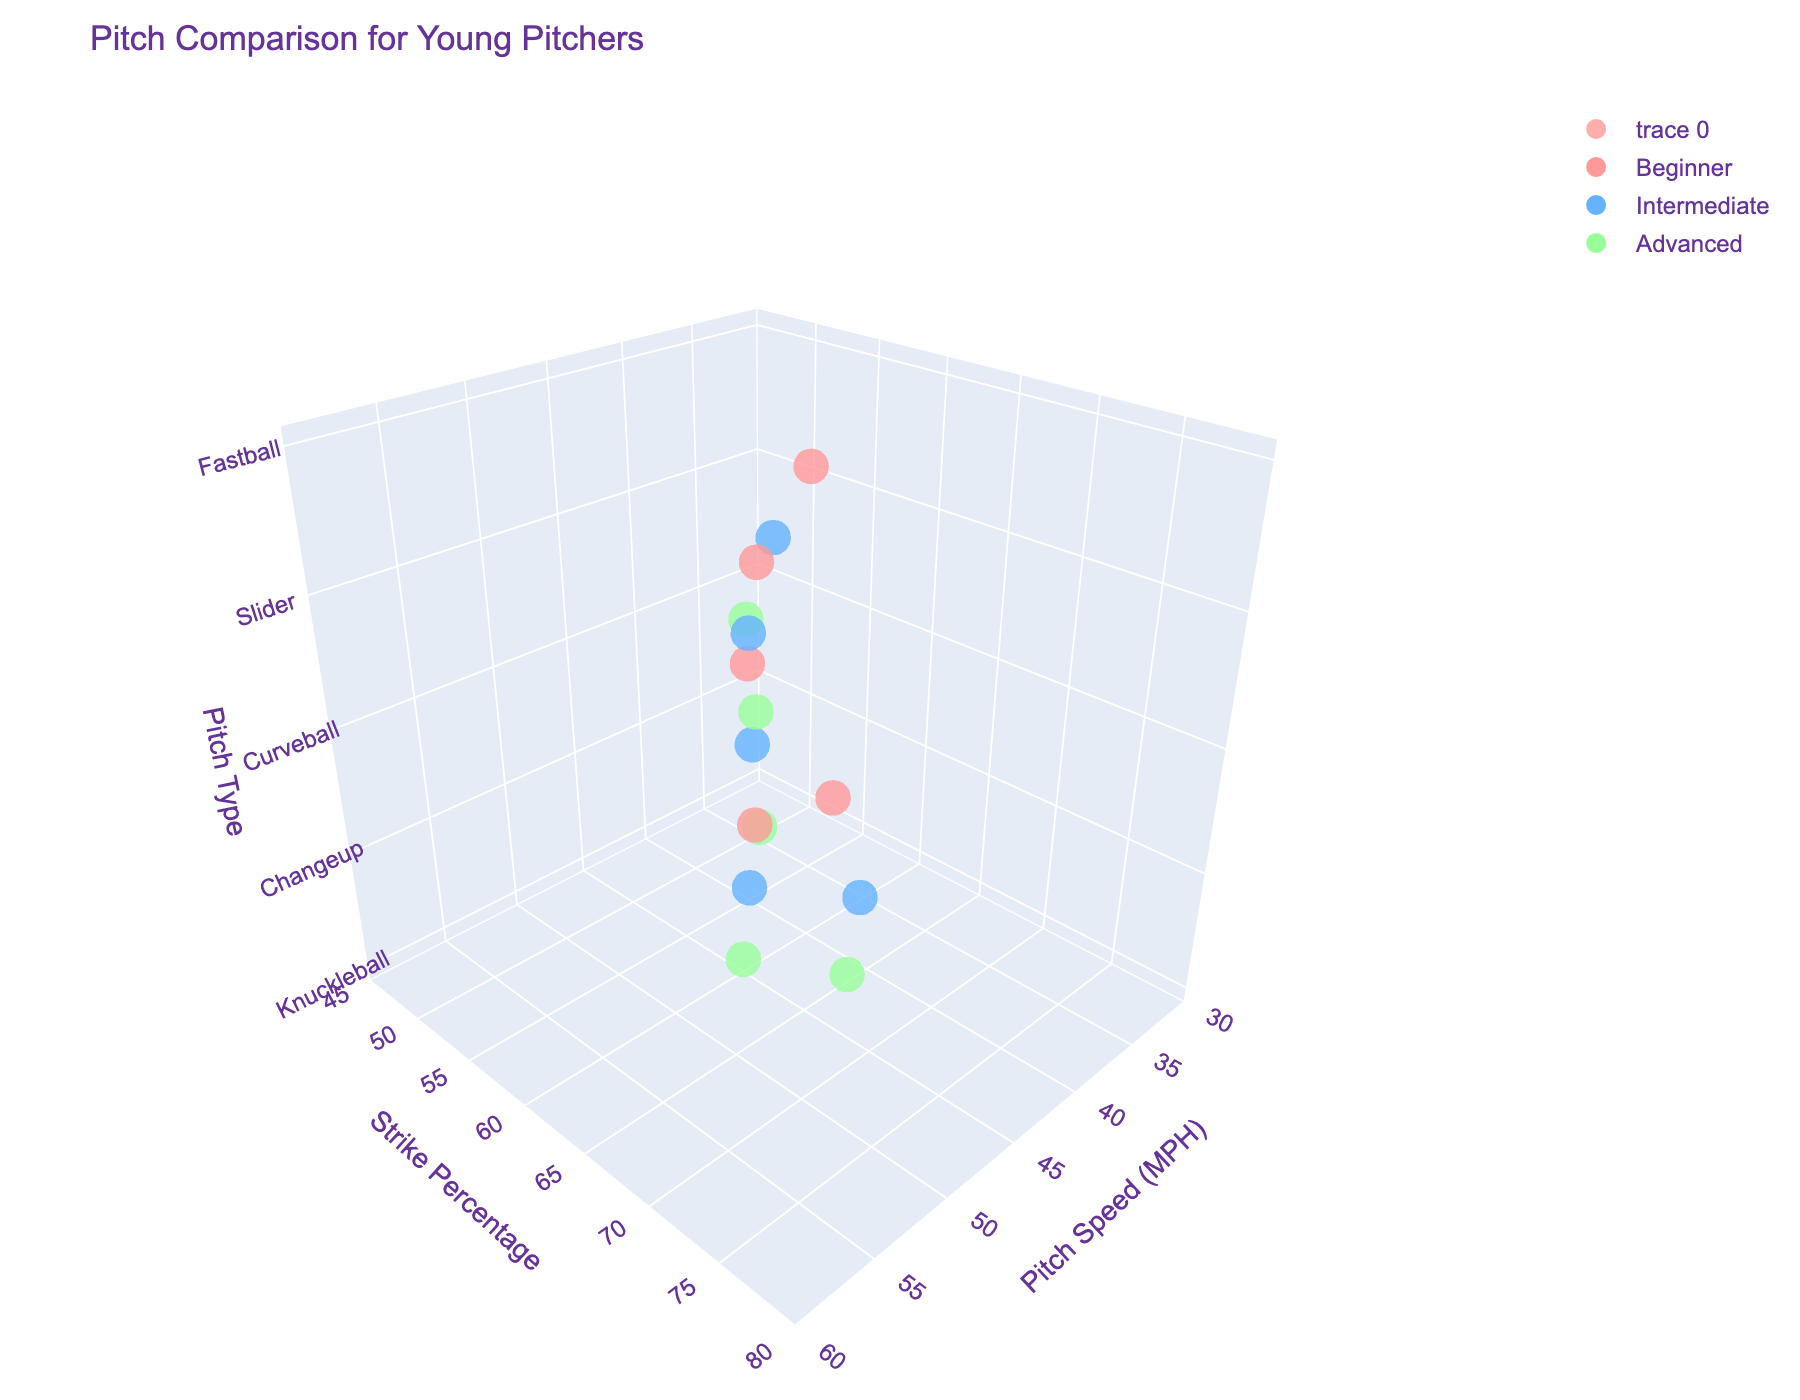What are the pitch types represented in the figure? The z-axis of the 3D scatter plot represents different pitch types. By observing the unique categories along the z-axis, we can identify all the pitch types involved.
Answer: Fastball, Changeup, Curveball, Slider, Knuckleball What is the maximum pitch speed for a Curveball? On the x-axis, which represents pitch speed in MPH, identify the maximum value corresponding to the points labeled as Curveball along the z-axis.
Answer: 51 MPH Which skill level has the highest strike percentage for a Fastball? Locate the points marked as Fastballs along the z-axis. Among these, find the point with the highest y-axis value (strike percentage) and check its associated skill level.
Answer: Advanced What's the difference in average pitch speed between Beginners and Advanced pitchers? For each skill level (Beginner and Advanced), average the pitch speeds across all pitch types. Subtract the Beginner average from the Advanced average to find the difference.
Answer: 10.5 MPH Which pitch type has the lowest maximum strike percentage, and what is that percentage? For each pitch type along the z-axis, find the point with the highest y-axis value (strike percentage). Among these, identify the pitch type with the lowest such value and its corresponding strike percentage.
Answer: Knuckleball, 60% What's the median strike percentage for Intermediate skill level pitchers? Obtain the strike percentage values for Intermediate pitchers across all pitch types. Order the percentages and find the median value.
Answer: 64% Do Advanced pitchers generally throw faster pitches than Intermediate ones? Compare the pitch speed values (x-axis) for data points associated with Intermediate and Advanced skill levels. Look for a general trend indicating higher speeds for Advanced pitchers.
Answer: Yes How does the strike percentage for Sliders compare between Beginner and Intermediate skill levels? Identify the points marked as Sliders. Compare the y-axis values (strike percentage) for points labeled as Beginner and Intermediate.
Answer: Intermediate is higher Which pitch type displays the greatest improvement in strike percentage from Beginner to Advanced levels? For each pitch type, calculate the difference in strike percentages between Advanced and Beginner levels. Identify the pitch type with the highest increase.
Answer: Changeup What's the overall trend in strike percentage as pitch speed increases? Examine the relationship between pitch speeds (x-axis) and strike percentage (y-axis) across all data points to identify a general trend.
Answer: Increase 